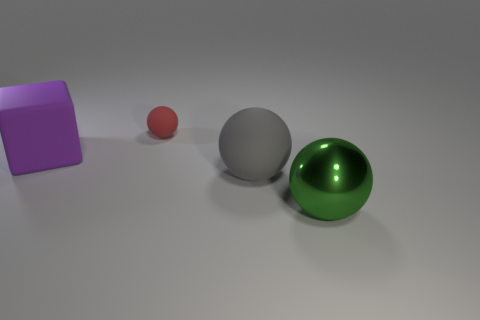Add 1 tiny blue balls. How many objects exist? 5 Subtract all balls. How many objects are left? 1 Subtract all tiny red balls. Subtract all small matte spheres. How many objects are left? 2 Add 2 metallic spheres. How many metallic spheres are left? 3 Add 2 large objects. How many large objects exist? 5 Subtract 0 cyan blocks. How many objects are left? 4 